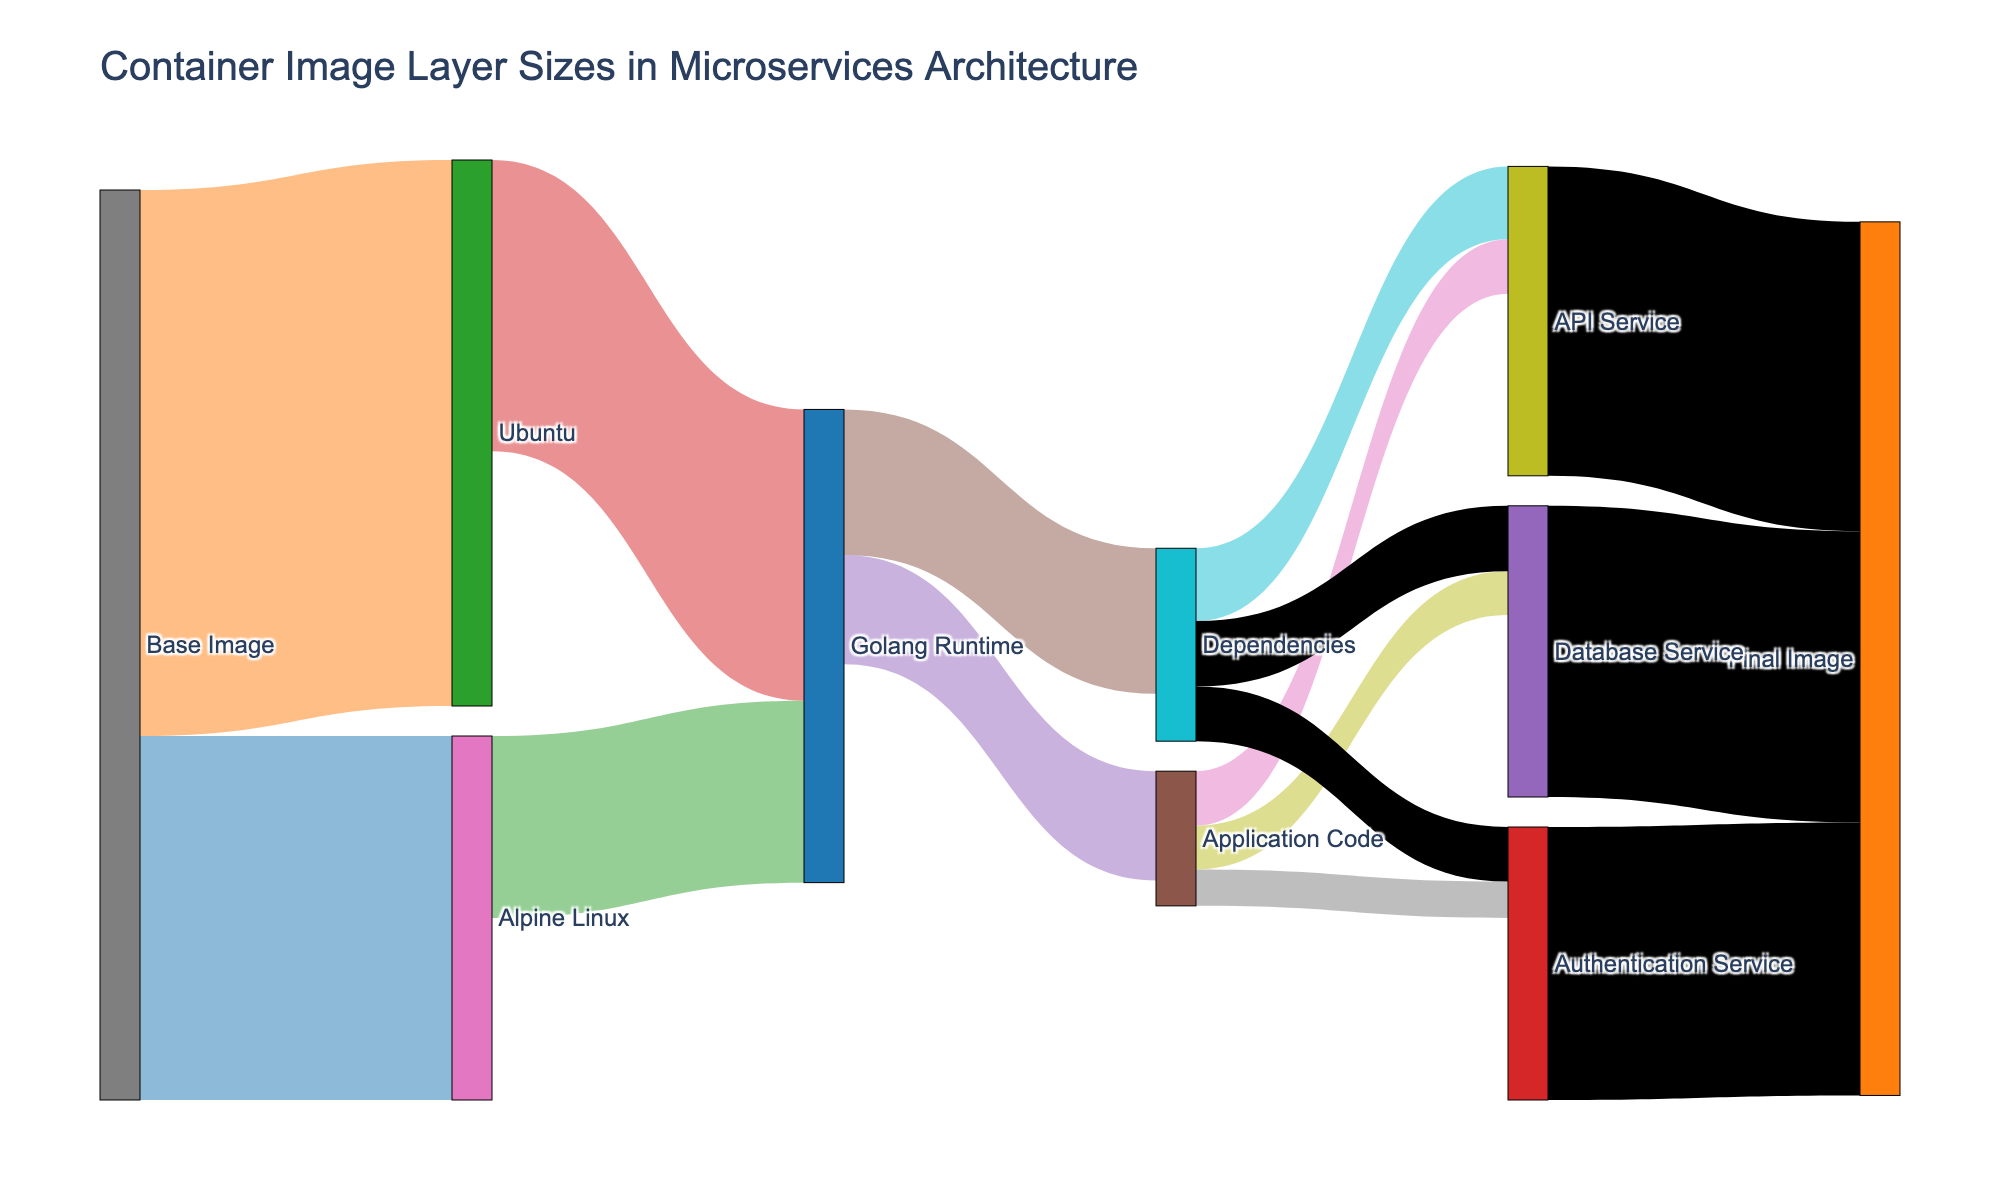What is the title of the diagram? The title is usually at the top of the diagram. In this case, we can see that it's set as "Container Image Layer Sizes in Microservices Architecture".
Answer: Container Image Layer Sizes in Microservices Architecture Which base image has the largest size? By inspecting the values flowing from the "Base Image", we notice the sizes. The "Ubuntu" base image has a value of 150, while "Alpine Linux" has 100. Therefore, "Ubuntu" has the largest size.
Answer: Ubuntu How many services are included in the diagram? We can count the services from the "Application Code" and the "Dependencies" nodes that lead to different services, which include "API Service", "Authentication Service", and "Database Service". That's a total of three services.
Answer: 3 What's the total size of dependencies for all services combined? To find this, sum the sizes of dependencies for each service. Dependencies to "API Service" are 20, "Authentication Service" are 15, and "Database Service" are 18. Adding these gives 20 + 15 + 18 = 53.
Answer: 53 What is the final image size of the "API Service"? Following the flow from the "API Service" to the "Final Image", it shows a value of 85.
Answer: 85 Compare the size of the Golang Runtime when using "Alpine Linux" versus "Ubuntu". Which is smaller? The "Golang Runtime" has a size of 50 when using "Alpine Linux" and 80 when using "Ubuntu". Comparing the two, 50 is smaller than 80.
Answer: Alpine Linux What is the combined size of the "Application Code" for all services? Adding the sizes of the "Application Code" to each service: 15 (API Service) + 10 (Authentication Service) + 12 (Database Service) = 37.
Answer: 37 What is the difference in final image size between "API Service" and "Authentication Service"? The final image size of the "API Service" is 85, and for "Authentication Service" it is 75. The difference is 85 - 75 = 10.
Answer: 10 Which service contributes the most to the final image size? By comparing the final image sizes of the services: "API Service" (85), "Authentication Service" (75), and "Database Service" (80), the "API Service" has the largest contribution with 85.
Answer: API Service What is the total size of the base images combined? The base images are "Alpine Linux" with a size of 100 and "Ubuntu" with a size of 150. Adding them gives 100 + 150 = 250.
Answer: 250 